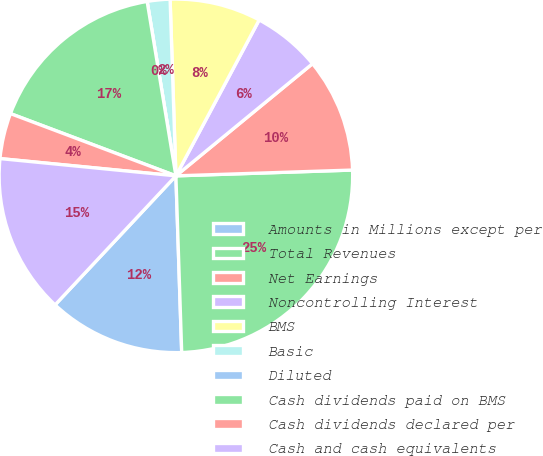Convert chart to OTSL. <chart><loc_0><loc_0><loc_500><loc_500><pie_chart><fcel>Amounts in Millions except per<fcel>Total Revenues<fcel>Net Earnings<fcel>Noncontrolling Interest<fcel>BMS<fcel>Basic<fcel>Diluted<fcel>Cash dividends paid on BMS<fcel>Cash dividends declared per<fcel>Cash and cash equivalents<nl><fcel>12.5%<fcel>25.0%<fcel>10.42%<fcel>6.25%<fcel>8.33%<fcel>2.08%<fcel>0.0%<fcel>16.67%<fcel>4.17%<fcel>14.58%<nl></chart> 